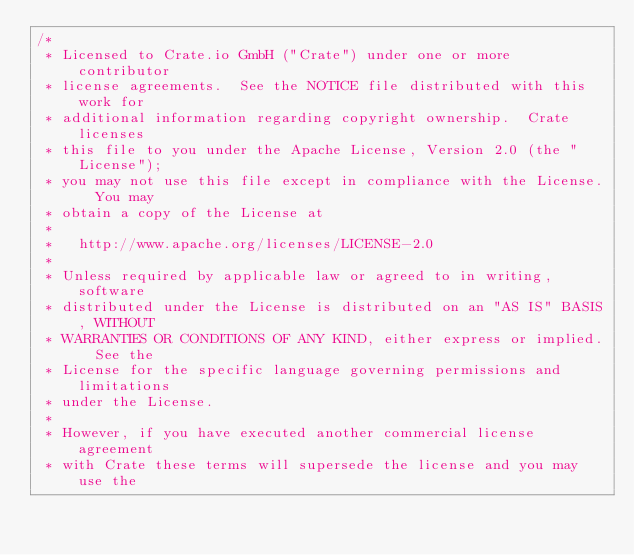Convert code to text. <code><loc_0><loc_0><loc_500><loc_500><_Java_>/*
 * Licensed to Crate.io GmbH ("Crate") under one or more contributor
 * license agreements.  See the NOTICE file distributed with this work for
 * additional information regarding copyright ownership.  Crate licenses
 * this file to you under the Apache License, Version 2.0 (the "License");
 * you may not use this file except in compliance with the License.  You may
 * obtain a copy of the License at
 *
 *   http://www.apache.org/licenses/LICENSE-2.0
 *
 * Unless required by applicable law or agreed to in writing, software
 * distributed under the License is distributed on an "AS IS" BASIS, WITHOUT
 * WARRANTIES OR CONDITIONS OF ANY KIND, either express or implied.  See the
 * License for the specific language governing permissions and limitations
 * under the License.
 *
 * However, if you have executed another commercial license agreement
 * with Crate these terms will supersede the license and you may use the</code> 